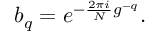Convert formula to latex. <formula><loc_0><loc_0><loc_500><loc_500>b _ { q } = e ^ { - { \frac { 2 \pi i } { N } } g ^ { - q } } .</formula> 